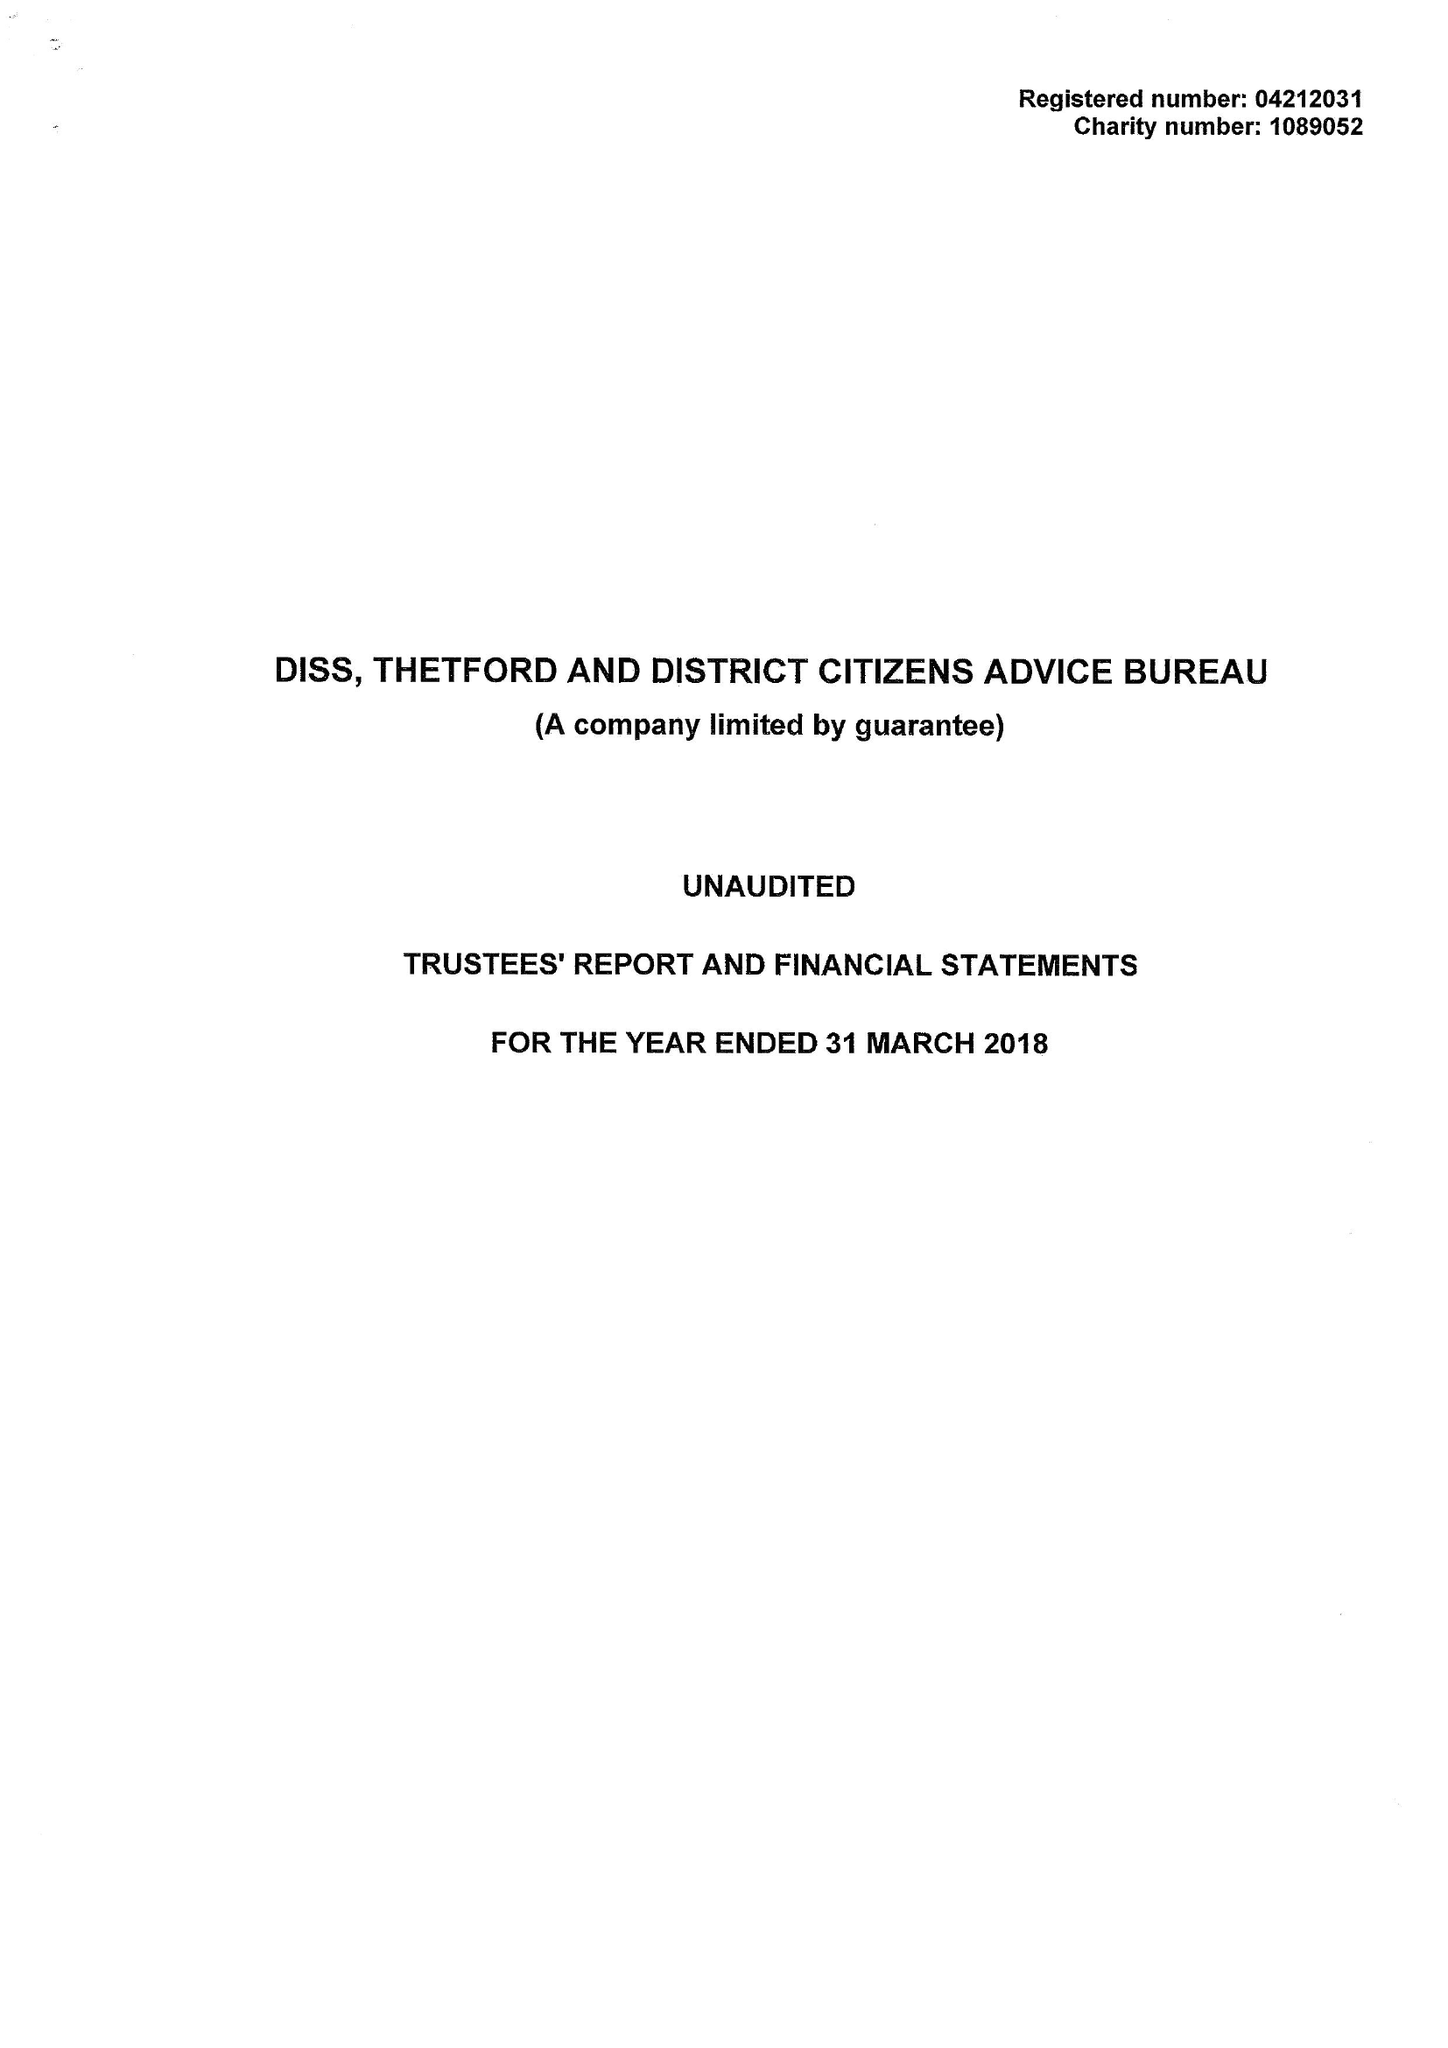What is the value for the report_date?
Answer the question using a single word or phrase. 2018-03-31 